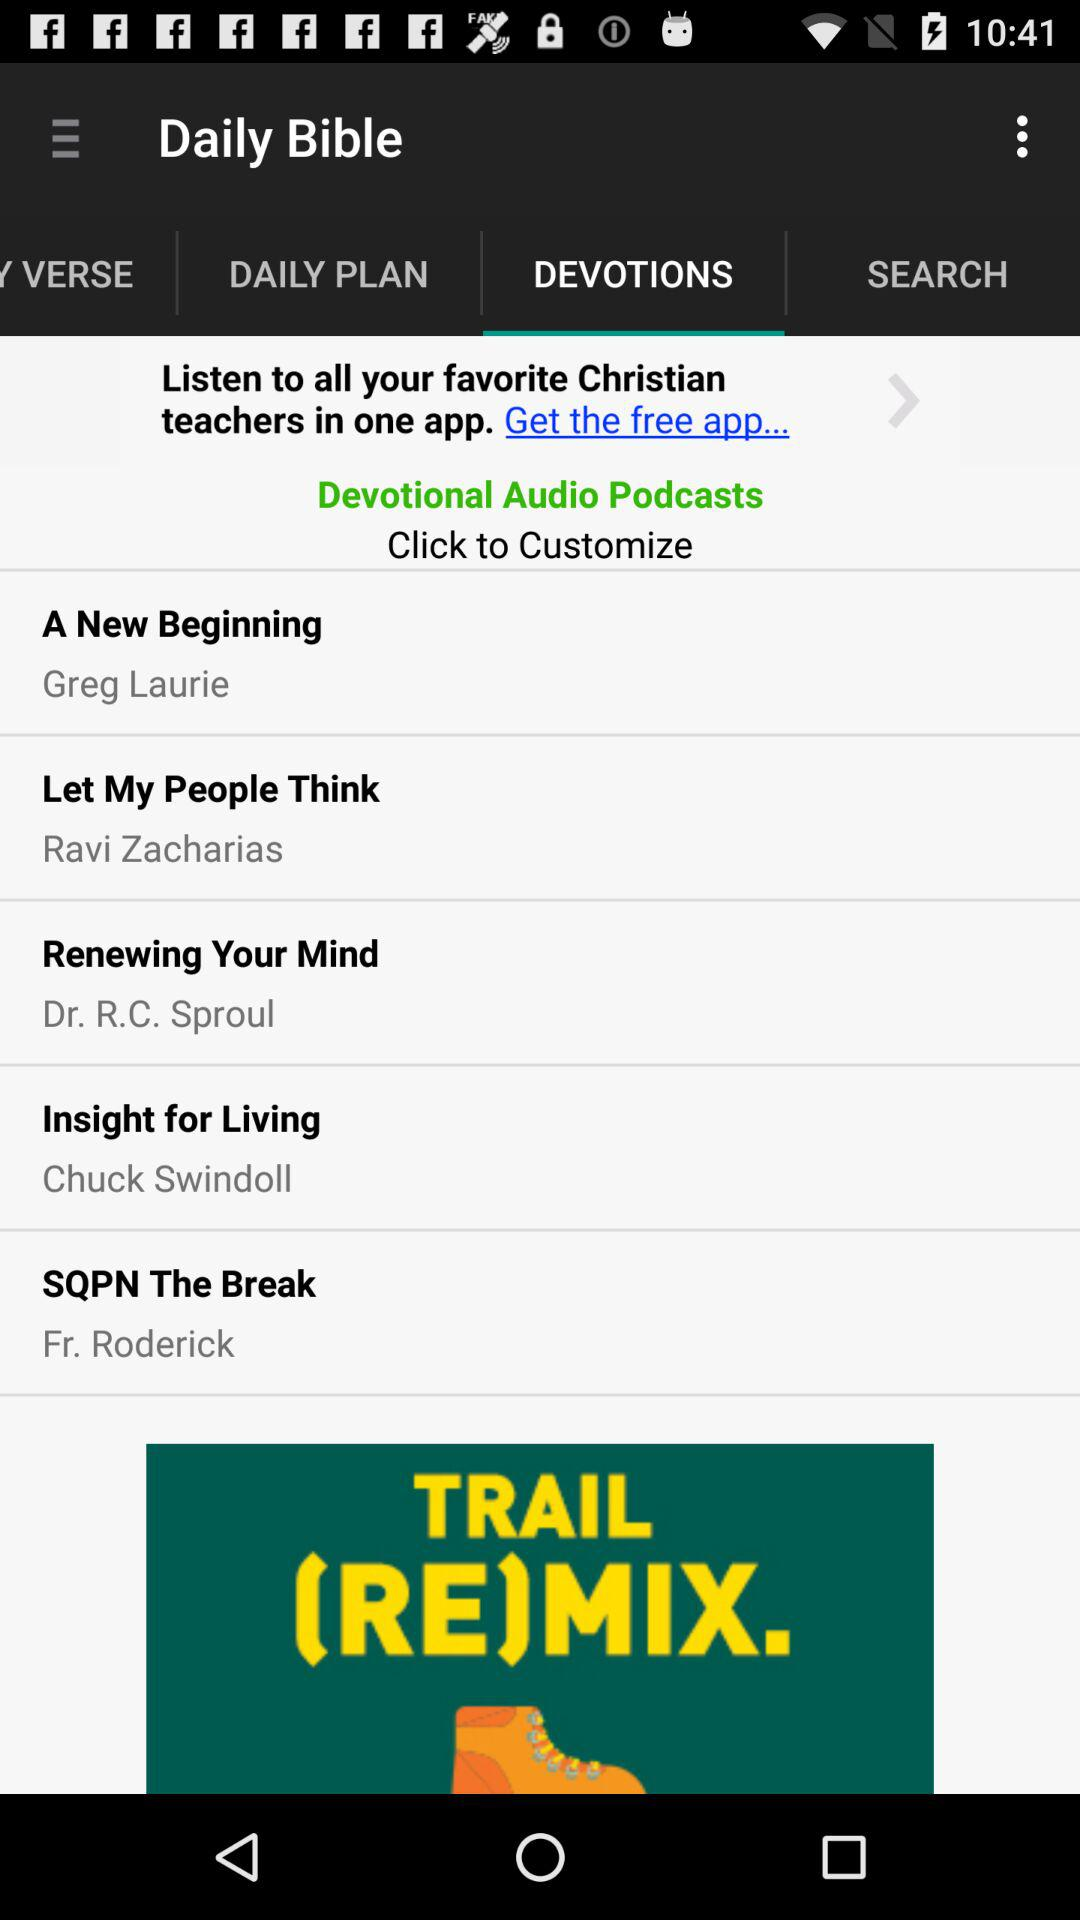Which option is selected in "Daily Bible"? The selected option is "DEVOTIONS". 